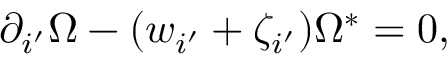<formula> <loc_0><loc_0><loc_500><loc_500>\partial _ { i ^ { \prime } } \Omega - ( w _ { i ^ { \prime } } + \zeta _ { i ^ { \prime } } ) \Omega ^ { \ast } = 0 ,</formula> 